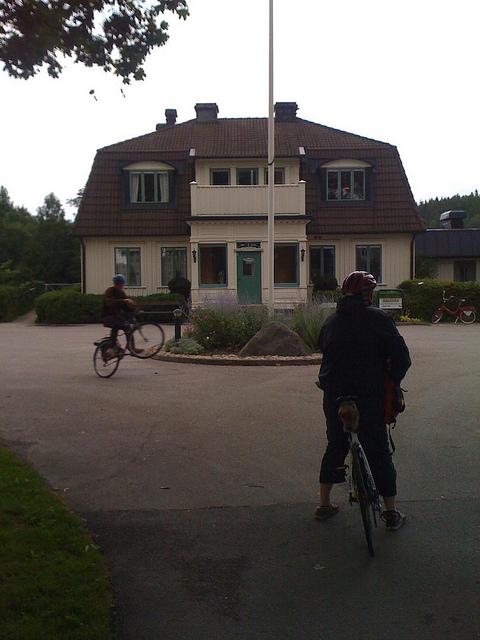Is this in the city?
Keep it brief. No. Is this a European house?
Give a very brief answer. Yes. What safety device are the riders using?
Be succinct. Helmets. Are they in a park?
Keep it brief. No. Do you see a horse?
Keep it brief. No. What is the weather like in the picture?
Be succinct. Cloudy. Is there a dog in this picture?
Be succinct. No. How many trees are in the picture?
Be succinct. 5. Is it a circular driveway?
Give a very brief answer. Yes. 